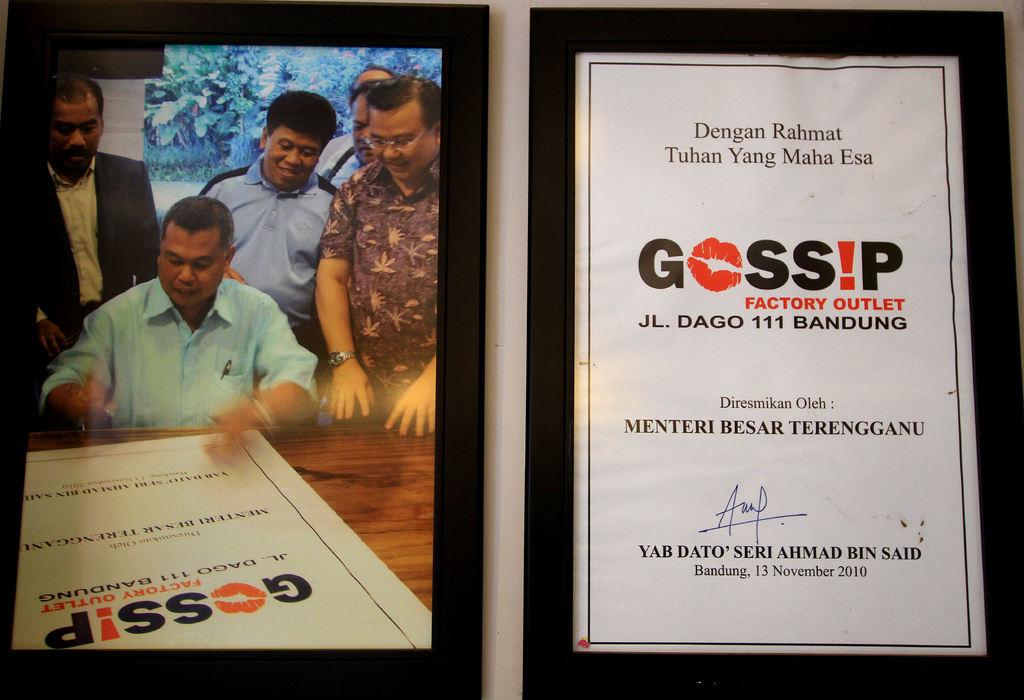What is the name of the outlet store?
Make the answer very short. Gossip. This is project banduing?
Your answer should be very brief. Yes. 